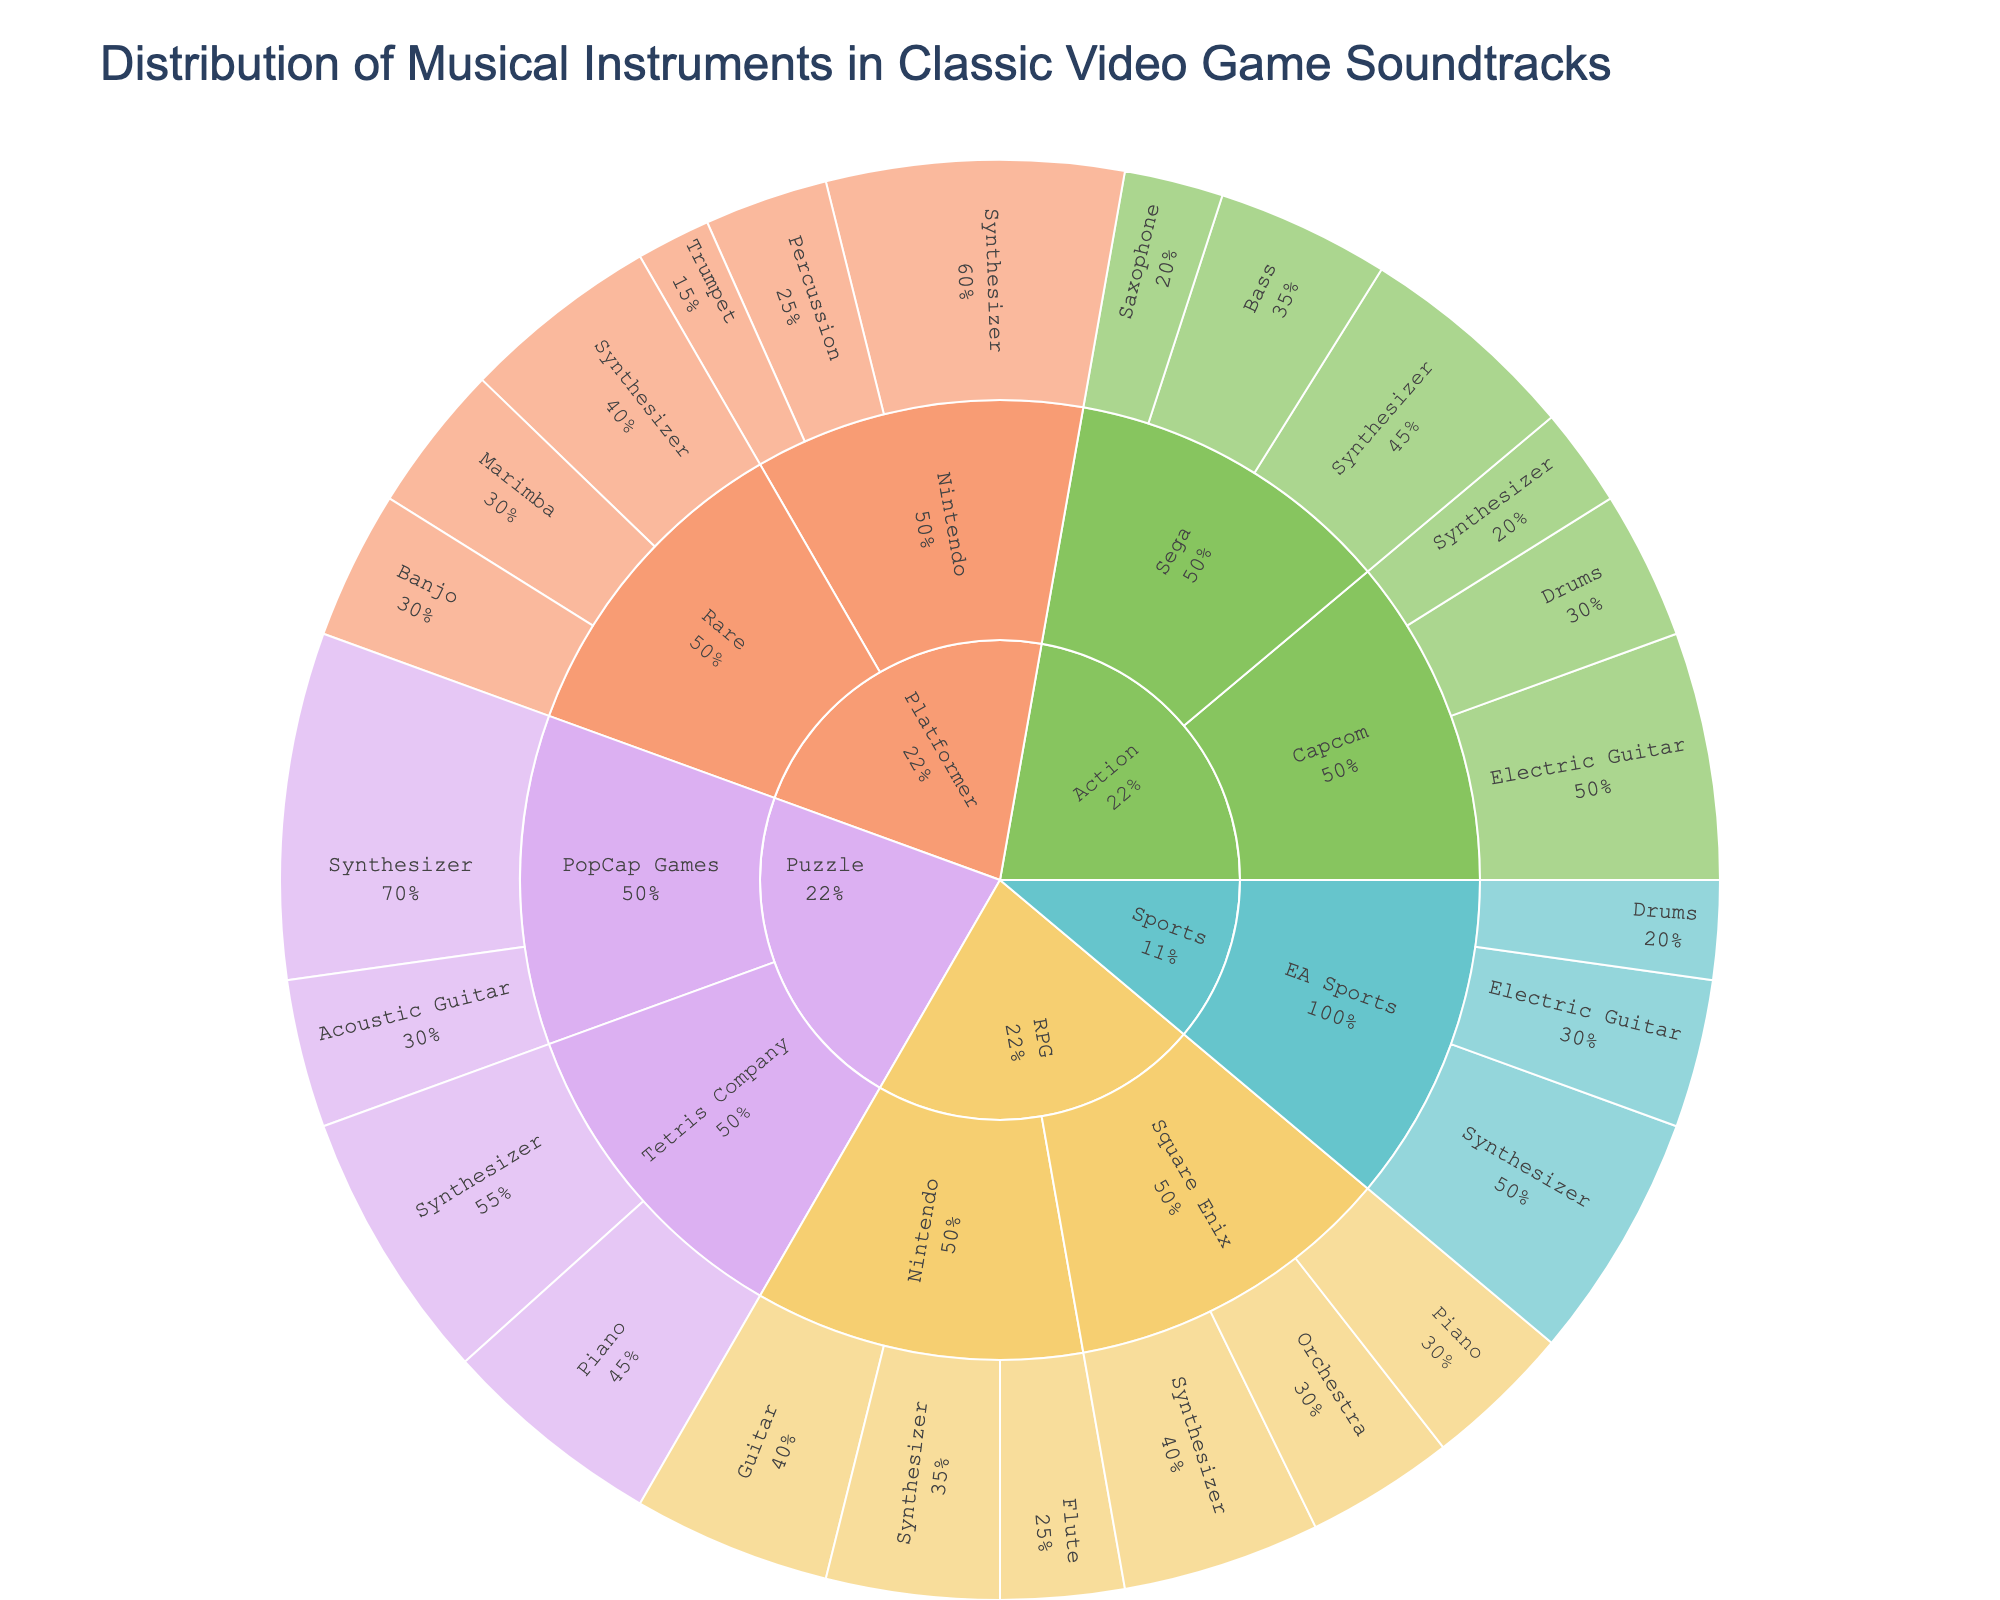Which genre has the highest percentage usage of synthesizers? Check each genre's synthesizer percentage usage. Observation shows RPG (Square Enix and Nintendo combined), Action (Capcom and Sega combined), Platformer (Nintendo and Rare combined), Puzzle (Tetris Company and PopCap Games combined), and Sports (EA Sports) usage. Puzzle has the highest combined percentage with 100%.
Answer: Puzzle Which instrument is most utilized by Nintendo across all genres? Look at all genres and check the usage percentages of instruments by Nintendo. Summing up within each genre (RPG, Platformer), the synthesizer has a total percentage of 95 (60 in Platformer + 35 in RPG).
Answer: Synthesizer Which developer uses electric guitars the most? Compare the electric guitar usage percentages of developers that list it. The available developers are Capcom in the Action genre with 50%, EA Sports in the Sports genre with 30%. Capcom has the highest usage.
Answer: Capcom What is the total percentage of piano usage across all genres? Sum up the percentages that include the piano instrument. RPG (Square Enix) has 30%, Puzzle (Tetris Company) has 45%. Total is 30% + 45% = 75%.
Answer: 75% How does the usage of orchestras in RPG by Square Enix compare to the usage of drums in Action by Capcom? Compare Orchestra usage (30%) in RPG by Square Enix with Drums usage (30%) in Action by Capcom. Both percentages are the same.
Answer: Equal What is the most frequently used instrument overall? Identify the instrument with the highest total percentage usage across all developers and genres. The Synthesizer appears most frequently and in large percentages (e.g., Puzzle 55% and 70%, RPG among others). Synthesizer is used the most frequently.
Answer: Synthesizer What percentage of platformer game soundtracks by Rare includes the marimba? Look at the usage percentage of the marimba by Rare in the Platformer genre. It is listed with a value of 30%.
Answer: 30% Compare the use of synthesizers by Sega in Action games to the use of synthesizers by PopCap Games in Puzzle games. Compare the percentages listed for Sega (45%) and PopCap Games (70%). PopCap Games uses synthesizers more (70% > 45%).
Answer: PopCap Games uses more What is the least utilized instrument in RPG games by Nintendo? Analyze the percentage usage of each instrument used by Nintendo in RPG games. Synthesizer (35%), Flute (25%), Guitar (40%). The flute has the least usage at 25%.
Answer: Flute What is the combined percentage usage of guitars (electric and acoustic) across all genres? Sum the relevant percentages: RPG (Nintendo, Guitar 40%), Puzzle (PopCap, Acoustic Guitar 30%), Action (Capcom, Electric Guitar 50%), Sports (EA Sports, Electric Guitar 30%). Combined: 40% + 30% + 50% + 30% = 150%.
Answer: 150% 